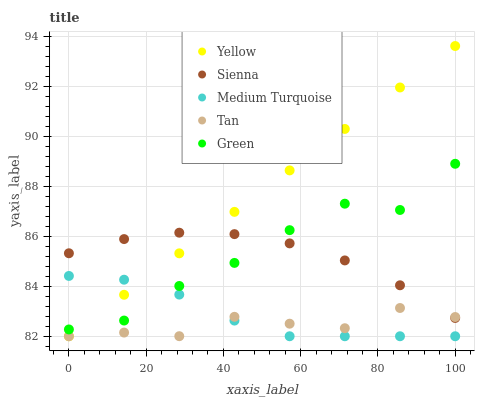Does Tan have the minimum area under the curve?
Answer yes or no. Yes. Does Yellow have the maximum area under the curve?
Answer yes or no. Yes. Does Green have the minimum area under the curve?
Answer yes or no. No. Does Green have the maximum area under the curve?
Answer yes or no. No. Is Yellow the smoothest?
Answer yes or no. Yes. Is Green the roughest?
Answer yes or no. Yes. Is Tan the smoothest?
Answer yes or no. No. Is Tan the roughest?
Answer yes or no. No. Does Tan have the lowest value?
Answer yes or no. Yes. Does Green have the lowest value?
Answer yes or no. No. Does Yellow have the highest value?
Answer yes or no. Yes. Does Green have the highest value?
Answer yes or no. No. Is Medium Turquoise less than Sienna?
Answer yes or no. Yes. Is Green greater than Tan?
Answer yes or no. Yes. Does Green intersect Medium Turquoise?
Answer yes or no. Yes. Is Green less than Medium Turquoise?
Answer yes or no. No. Is Green greater than Medium Turquoise?
Answer yes or no. No. Does Medium Turquoise intersect Sienna?
Answer yes or no. No. 